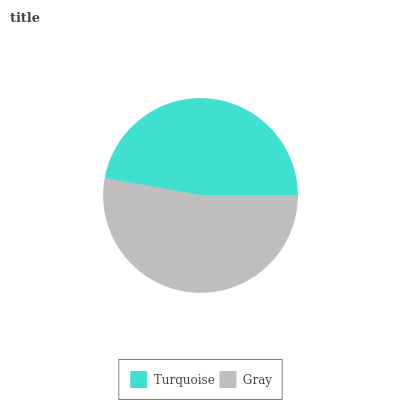Is Turquoise the minimum?
Answer yes or no. Yes. Is Gray the maximum?
Answer yes or no. Yes. Is Gray the minimum?
Answer yes or no. No. Is Gray greater than Turquoise?
Answer yes or no. Yes. Is Turquoise less than Gray?
Answer yes or no. Yes. Is Turquoise greater than Gray?
Answer yes or no. No. Is Gray less than Turquoise?
Answer yes or no. No. Is Gray the high median?
Answer yes or no. Yes. Is Turquoise the low median?
Answer yes or no. Yes. Is Turquoise the high median?
Answer yes or no. No. Is Gray the low median?
Answer yes or no. No. 